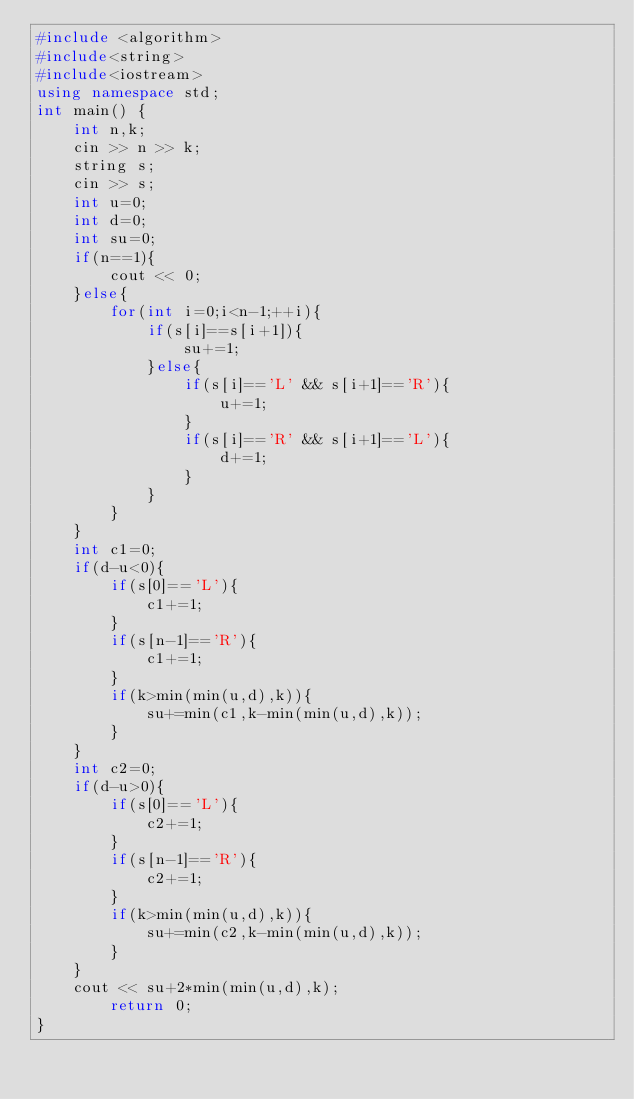Convert code to text. <code><loc_0><loc_0><loc_500><loc_500><_C++_>#include <algorithm>
#include<string>
#include<iostream>
using namespace std;
int main() {
    int n,k;
    cin >> n >> k;
    string s;
    cin >> s;
    int u=0;
    int d=0;
    int su=0;
    if(n==1){
        cout << 0;
    }else{
        for(int i=0;i<n-1;++i){
            if(s[i]==s[i+1]){
                su+=1;
            }else{
                if(s[i]=='L' && s[i+1]=='R'){
                    u+=1;
                }
                if(s[i]=='R' && s[i+1]=='L'){
                    d+=1;
                }
            }
        }
    }
    int c1=0;
    if(d-u<0){
        if(s[0]=='L'){
            c1+=1;
        }
        if(s[n-1]=='R'){
            c1+=1;
        }
        if(k>min(min(u,d),k)){
            su+=min(c1,k-min(min(u,d),k));
        }
    }
    int c2=0;
    if(d-u>0){
        if(s[0]=='L'){
            c2+=1;
        }
        if(s[n-1]=='R'){
            c2+=1;
        }
        if(k>min(min(u,d),k)){
            su+=min(c2,k-min(min(u,d),k));
        }
    }
    cout << su+2*min(min(u,d),k);
        return 0;
}
</code> 